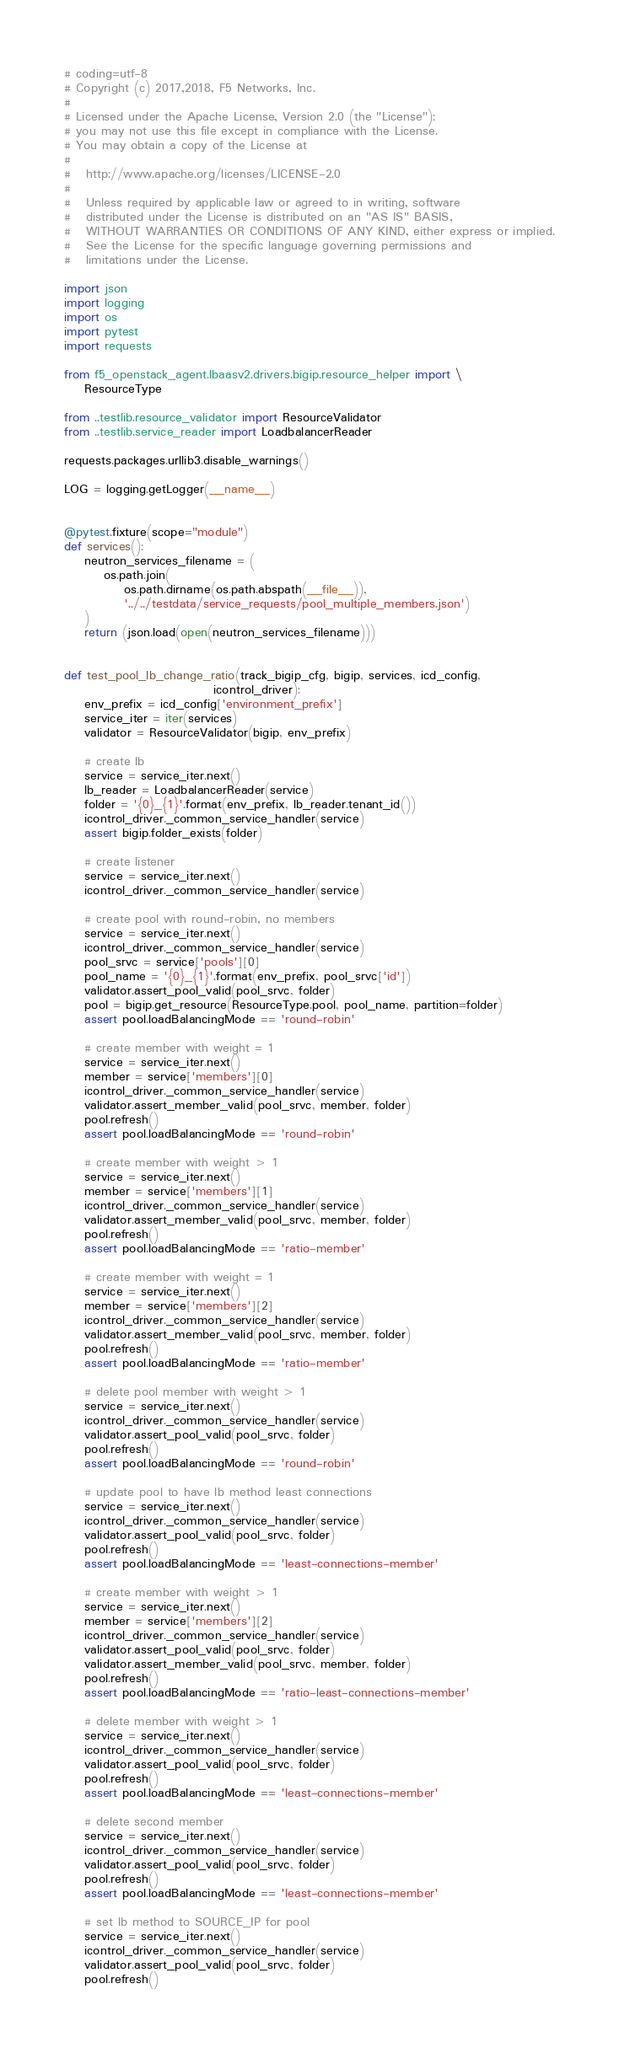<code> <loc_0><loc_0><loc_500><loc_500><_Python_># coding=utf-8
# Copyright (c) 2017,2018, F5 Networks, Inc.
#
# Licensed under the Apache License, Version 2.0 (the "License");
# you may not use this file except in compliance with the License.
# You may obtain a copy of the License at
#
#   http://www.apache.org/licenses/LICENSE-2.0
#
#   Unless required by applicable law or agreed to in writing, software
#   distributed under the License is distributed on an "AS IS" BASIS,
#   WITHOUT WARRANTIES OR CONDITIONS OF ANY KIND, either express or implied.
#   See the License for the specific language governing permissions and
#   limitations under the License.

import json
import logging
import os
import pytest
import requests

from f5_openstack_agent.lbaasv2.drivers.bigip.resource_helper import \
    ResourceType

from ..testlib.resource_validator import ResourceValidator
from ..testlib.service_reader import LoadbalancerReader

requests.packages.urllib3.disable_warnings()

LOG = logging.getLogger(__name__)


@pytest.fixture(scope="module")
def services():
    neutron_services_filename = (
        os.path.join(
            os.path.dirname(os.path.abspath(__file__)),
            '../../testdata/service_requests/pool_multiple_members.json')
    )
    return (json.load(open(neutron_services_filename)))


def test_pool_lb_change_ratio(track_bigip_cfg, bigip, services, icd_config,
                              icontrol_driver):
    env_prefix = icd_config['environment_prefix']
    service_iter = iter(services)
    validator = ResourceValidator(bigip, env_prefix)

    # create lb
    service = service_iter.next()
    lb_reader = LoadbalancerReader(service)
    folder = '{0}_{1}'.format(env_prefix, lb_reader.tenant_id())
    icontrol_driver._common_service_handler(service)
    assert bigip.folder_exists(folder)

    # create listener
    service = service_iter.next()
    icontrol_driver._common_service_handler(service)

    # create pool with round-robin, no members
    service = service_iter.next()
    icontrol_driver._common_service_handler(service)
    pool_srvc = service['pools'][0]
    pool_name = '{0}_{1}'.format(env_prefix, pool_srvc['id'])
    validator.assert_pool_valid(pool_srvc, folder)
    pool = bigip.get_resource(ResourceType.pool, pool_name, partition=folder)
    assert pool.loadBalancingMode == 'round-robin'

    # create member with weight = 1
    service = service_iter.next()
    member = service['members'][0]
    icontrol_driver._common_service_handler(service)
    validator.assert_member_valid(pool_srvc, member, folder)
    pool.refresh()
    assert pool.loadBalancingMode == 'round-robin'

    # create member with weight > 1
    service = service_iter.next()
    member = service['members'][1]
    icontrol_driver._common_service_handler(service)
    validator.assert_member_valid(pool_srvc, member, folder)
    pool.refresh()
    assert pool.loadBalancingMode == 'ratio-member'

    # create member with weight = 1
    service = service_iter.next()
    member = service['members'][2]
    icontrol_driver._common_service_handler(service)
    validator.assert_member_valid(pool_srvc, member, folder)
    pool.refresh()
    assert pool.loadBalancingMode == 'ratio-member'

    # delete pool member with weight > 1
    service = service_iter.next()
    icontrol_driver._common_service_handler(service)
    validator.assert_pool_valid(pool_srvc, folder)
    pool.refresh()
    assert pool.loadBalancingMode == 'round-robin'

    # update pool to have lb method least connections
    service = service_iter.next()
    icontrol_driver._common_service_handler(service)
    validator.assert_pool_valid(pool_srvc, folder)
    pool.refresh()
    assert pool.loadBalancingMode == 'least-connections-member'

    # create member with weight > 1
    service = service_iter.next()
    member = service['members'][2]
    icontrol_driver._common_service_handler(service)
    validator.assert_pool_valid(pool_srvc, folder)
    validator.assert_member_valid(pool_srvc, member, folder)
    pool.refresh()
    assert pool.loadBalancingMode == 'ratio-least-connections-member'

    # delete member with weight > 1
    service = service_iter.next()
    icontrol_driver._common_service_handler(service)
    validator.assert_pool_valid(pool_srvc, folder)
    pool.refresh()
    assert pool.loadBalancingMode == 'least-connections-member'

    # delete second member
    service = service_iter.next()
    icontrol_driver._common_service_handler(service)
    validator.assert_pool_valid(pool_srvc, folder)
    pool.refresh()
    assert pool.loadBalancingMode == 'least-connections-member'

    # set lb method to SOURCE_IP for pool
    service = service_iter.next()
    icontrol_driver._common_service_handler(service)
    validator.assert_pool_valid(pool_srvc, folder)
    pool.refresh()</code> 